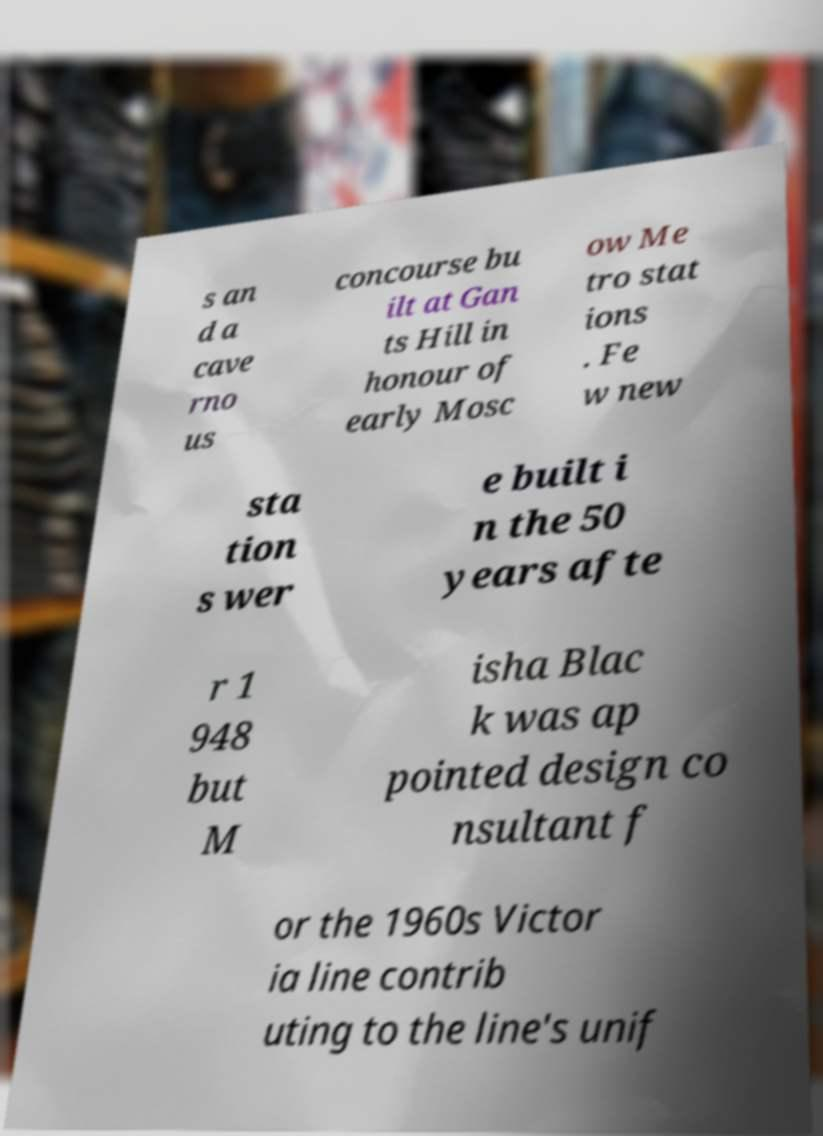What messages or text are displayed in this image? I need them in a readable, typed format. s an d a cave rno us concourse bu ilt at Gan ts Hill in honour of early Mosc ow Me tro stat ions . Fe w new sta tion s wer e built i n the 50 years afte r 1 948 but M isha Blac k was ap pointed design co nsultant f or the 1960s Victor ia line contrib uting to the line's unif 